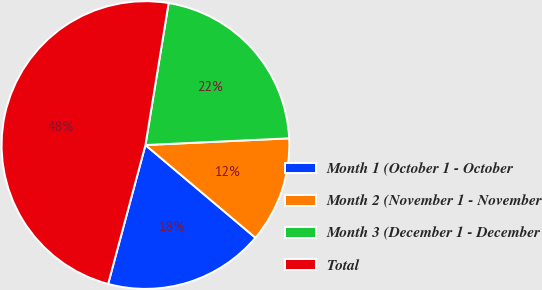<chart> <loc_0><loc_0><loc_500><loc_500><pie_chart><fcel>Month 1 (October 1 - October<fcel>Month 2 (November 1 - November<fcel>Month 3 (December 1 - December<fcel>Total<nl><fcel>18.03%<fcel>11.89%<fcel>21.68%<fcel>48.4%<nl></chart> 